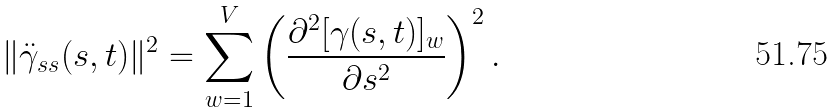<formula> <loc_0><loc_0><loc_500><loc_500>\| \ddot { \gamma } _ { s s } ( s , t ) \| ^ { 2 } & = \sum _ { w = 1 } ^ { V } \left ( \frac { \partial ^ { 2 } [ \gamma ( s , t ) ] _ { w } } { \partial s ^ { 2 } } \right ) ^ { 2 } .</formula> 